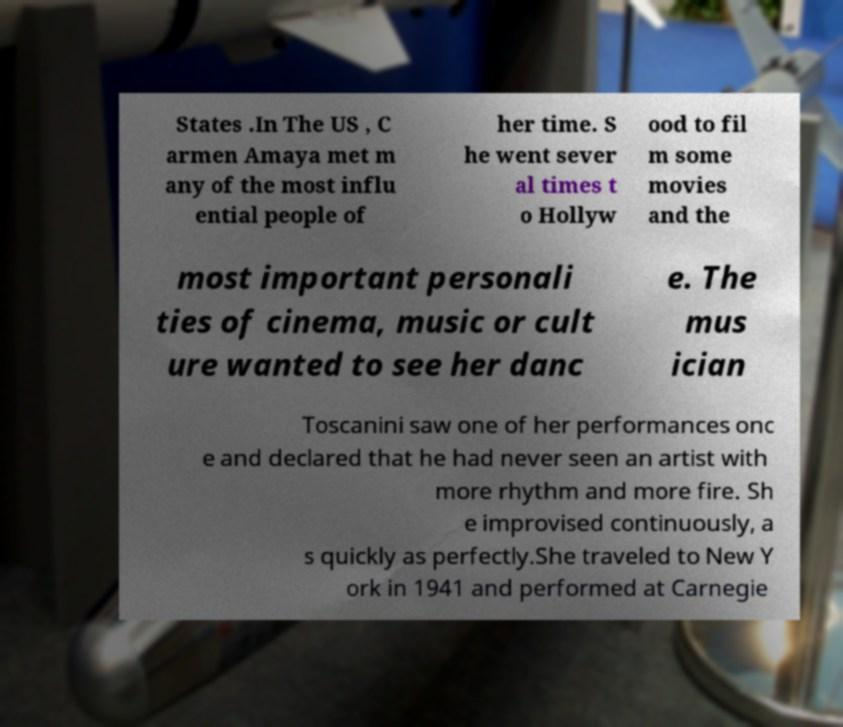Can you read and provide the text displayed in the image?This photo seems to have some interesting text. Can you extract and type it out for me? States .In The US , C armen Amaya met m any of the most influ ential people of her time. S he went sever al times t o Hollyw ood to fil m some movies and the most important personali ties of cinema, music or cult ure wanted to see her danc e. The mus ician Toscanini saw one of her performances onc e and declared that he had never seen an artist with more rhythm and more fire. Sh e improvised continuously, a s quickly as perfectly.She traveled to New Y ork in 1941 and performed at Carnegie 